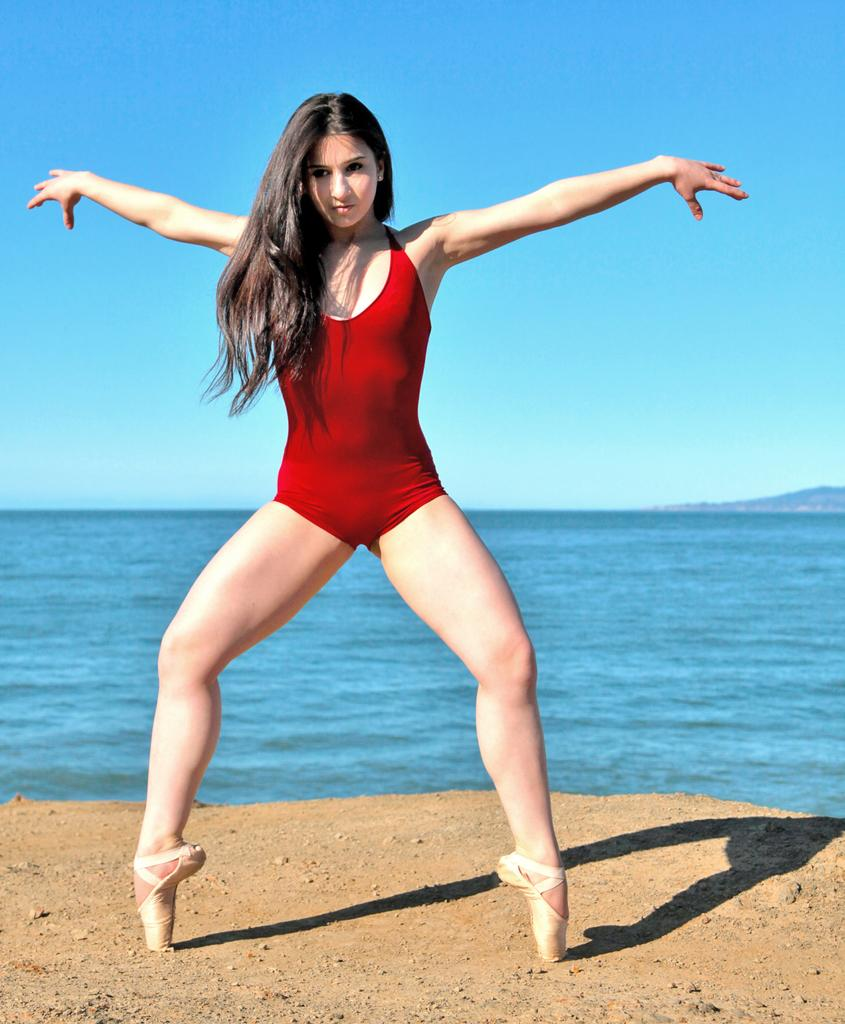Who is the main subject in the image? There is a woman in the image. What is the woman doing in the image? The woman is standing on her toes. What can be seen in the background of the image? There is water visible in the image. What is the color of the sky in the image? The sky is blue in the image. What type of robin can be seen singing in the image? There is no robin present in the image; it features a woman standing on her toes. How does the woman's death affect the image? There is no indication of the woman's death in the image, as she is standing on her toes. 